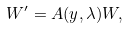<formula> <loc_0><loc_0><loc_500><loc_500>W ^ { \prime } = A ( y , \lambda ) W ,</formula> 